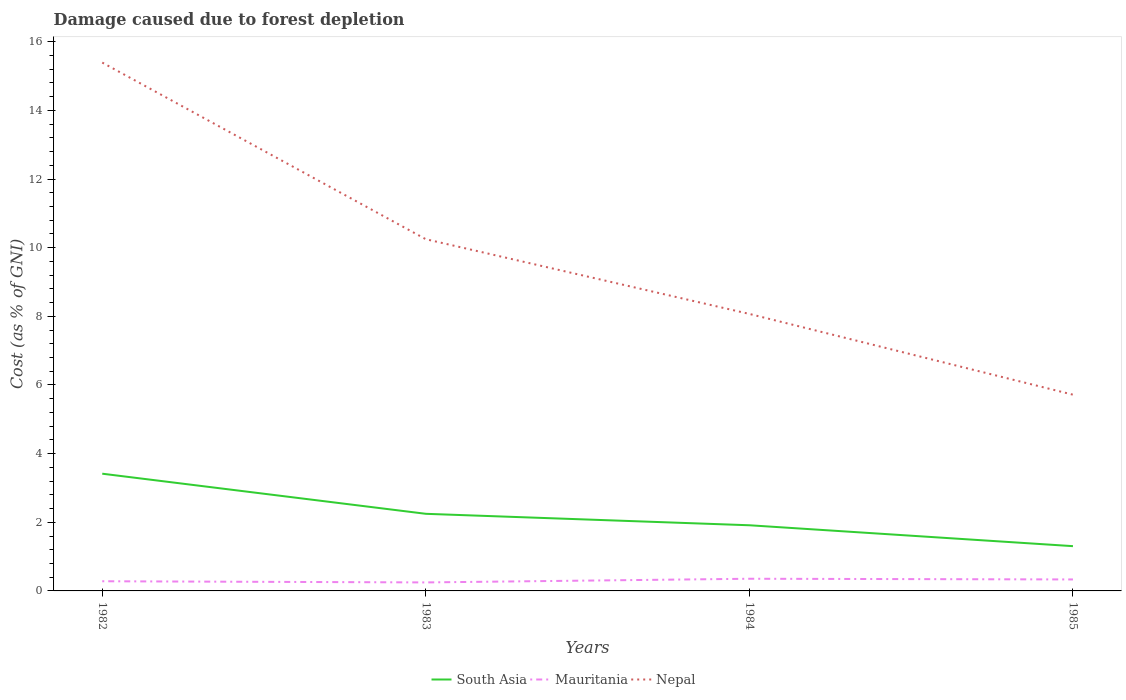Does the line corresponding to South Asia intersect with the line corresponding to Nepal?
Your response must be concise. No. Is the number of lines equal to the number of legend labels?
Make the answer very short. Yes. Across all years, what is the maximum cost of damage caused due to forest depletion in Mauritania?
Offer a very short reply. 0.25. In which year was the cost of damage caused due to forest depletion in South Asia maximum?
Give a very brief answer. 1985. What is the total cost of damage caused due to forest depletion in Mauritania in the graph?
Your answer should be compact. 0.03. What is the difference between the highest and the second highest cost of damage caused due to forest depletion in Nepal?
Your answer should be compact. 9.68. Is the cost of damage caused due to forest depletion in Nepal strictly greater than the cost of damage caused due to forest depletion in South Asia over the years?
Your response must be concise. No. How many lines are there?
Offer a very short reply. 3. Where does the legend appear in the graph?
Offer a very short reply. Bottom center. How many legend labels are there?
Ensure brevity in your answer.  3. How are the legend labels stacked?
Offer a very short reply. Horizontal. What is the title of the graph?
Ensure brevity in your answer.  Damage caused due to forest depletion. Does "Iceland" appear as one of the legend labels in the graph?
Your answer should be very brief. No. What is the label or title of the Y-axis?
Provide a succinct answer. Cost (as % of GNI). What is the Cost (as % of GNI) in South Asia in 1982?
Offer a very short reply. 3.42. What is the Cost (as % of GNI) in Mauritania in 1982?
Ensure brevity in your answer.  0.28. What is the Cost (as % of GNI) in Nepal in 1982?
Offer a very short reply. 15.39. What is the Cost (as % of GNI) of South Asia in 1983?
Provide a short and direct response. 2.25. What is the Cost (as % of GNI) of Mauritania in 1983?
Keep it short and to the point. 0.25. What is the Cost (as % of GNI) of Nepal in 1983?
Provide a short and direct response. 10.25. What is the Cost (as % of GNI) of South Asia in 1984?
Provide a short and direct response. 1.91. What is the Cost (as % of GNI) in Mauritania in 1984?
Offer a very short reply. 0.35. What is the Cost (as % of GNI) of Nepal in 1984?
Provide a succinct answer. 8.07. What is the Cost (as % of GNI) of South Asia in 1985?
Offer a terse response. 1.3. What is the Cost (as % of GNI) of Mauritania in 1985?
Make the answer very short. 0.33. What is the Cost (as % of GNI) in Nepal in 1985?
Your response must be concise. 5.72. Across all years, what is the maximum Cost (as % of GNI) of South Asia?
Offer a very short reply. 3.42. Across all years, what is the maximum Cost (as % of GNI) of Mauritania?
Keep it short and to the point. 0.35. Across all years, what is the maximum Cost (as % of GNI) of Nepal?
Make the answer very short. 15.39. Across all years, what is the minimum Cost (as % of GNI) in South Asia?
Offer a very short reply. 1.3. Across all years, what is the minimum Cost (as % of GNI) in Mauritania?
Provide a succinct answer. 0.25. Across all years, what is the minimum Cost (as % of GNI) in Nepal?
Offer a very short reply. 5.72. What is the total Cost (as % of GNI) of South Asia in the graph?
Your answer should be very brief. 8.88. What is the total Cost (as % of GNI) of Mauritania in the graph?
Your answer should be compact. 1.22. What is the total Cost (as % of GNI) in Nepal in the graph?
Ensure brevity in your answer.  39.43. What is the difference between the Cost (as % of GNI) of South Asia in 1982 and that in 1983?
Your response must be concise. 1.17. What is the difference between the Cost (as % of GNI) in Mauritania in 1982 and that in 1983?
Give a very brief answer. 0.03. What is the difference between the Cost (as % of GNI) in Nepal in 1982 and that in 1983?
Your response must be concise. 5.15. What is the difference between the Cost (as % of GNI) in South Asia in 1982 and that in 1984?
Ensure brevity in your answer.  1.5. What is the difference between the Cost (as % of GNI) of Mauritania in 1982 and that in 1984?
Your answer should be compact. -0.07. What is the difference between the Cost (as % of GNI) in Nepal in 1982 and that in 1984?
Give a very brief answer. 7.32. What is the difference between the Cost (as % of GNI) of South Asia in 1982 and that in 1985?
Keep it short and to the point. 2.11. What is the difference between the Cost (as % of GNI) in Mauritania in 1982 and that in 1985?
Offer a terse response. -0.05. What is the difference between the Cost (as % of GNI) of Nepal in 1982 and that in 1985?
Give a very brief answer. 9.68. What is the difference between the Cost (as % of GNI) of South Asia in 1983 and that in 1984?
Your response must be concise. 0.33. What is the difference between the Cost (as % of GNI) in Mauritania in 1983 and that in 1984?
Your answer should be very brief. -0.11. What is the difference between the Cost (as % of GNI) in Nepal in 1983 and that in 1984?
Offer a terse response. 2.18. What is the difference between the Cost (as % of GNI) of South Asia in 1983 and that in 1985?
Give a very brief answer. 0.94. What is the difference between the Cost (as % of GNI) in Mauritania in 1983 and that in 1985?
Keep it short and to the point. -0.09. What is the difference between the Cost (as % of GNI) of Nepal in 1983 and that in 1985?
Offer a very short reply. 4.53. What is the difference between the Cost (as % of GNI) of South Asia in 1984 and that in 1985?
Provide a short and direct response. 0.61. What is the difference between the Cost (as % of GNI) of Mauritania in 1984 and that in 1985?
Offer a very short reply. 0.02. What is the difference between the Cost (as % of GNI) in Nepal in 1984 and that in 1985?
Provide a succinct answer. 2.35. What is the difference between the Cost (as % of GNI) in South Asia in 1982 and the Cost (as % of GNI) in Mauritania in 1983?
Offer a very short reply. 3.17. What is the difference between the Cost (as % of GNI) of South Asia in 1982 and the Cost (as % of GNI) of Nepal in 1983?
Your response must be concise. -6.83. What is the difference between the Cost (as % of GNI) of Mauritania in 1982 and the Cost (as % of GNI) of Nepal in 1983?
Offer a terse response. -9.97. What is the difference between the Cost (as % of GNI) in South Asia in 1982 and the Cost (as % of GNI) in Mauritania in 1984?
Keep it short and to the point. 3.06. What is the difference between the Cost (as % of GNI) in South Asia in 1982 and the Cost (as % of GNI) in Nepal in 1984?
Keep it short and to the point. -4.66. What is the difference between the Cost (as % of GNI) of Mauritania in 1982 and the Cost (as % of GNI) of Nepal in 1984?
Your answer should be very brief. -7.79. What is the difference between the Cost (as % of GNI) of South Asia in 1982 and the Cost (as % of GNI) of Mauritania in 1985?
Offer a terse response. 3.08. What is the difference between the Cost (as % of GNI) of South Asia in 1982 and the Cost (as % of GNI) of Nepal in 1985?
Your response must be concise. -2.3. What is the difference between the Cost (as % of GNI) of Mauritania in 1982 and the Cost (as % of GNI) of Nepal in 1985?
Your answer should be very brief. -5.44. What is the difference between the Cost (as % of GNI) in South Asia in 1983 and the Cost (as % of GNI) in Mauritania in 1984?
Offer a terse response. 1.89. What is the difference between the Cost (as % of GNI) in South Asia in 1983 and the Cost (as % of GNI) in Nepal in 1984?
Offer a very short reply. -5.82. What is the difference between the Cost (as % of GNI) of Mauritania in 1983 and the Cost (as % of GNI) of Nepal in 1984?
Offer a very short reply. -7.82. What is the difference between the Cost (as % of GNI) in South Asia in 1983 and the Cost (as % of GNI) in Mauritania in 1985?
Provide a succinct answer. 1.91. What is the difference between the Cost (as % of GNI) in South Asia in 1983 and the Cost (as % of GNI) in Nepal in 1985?
Your answer should be very brief. -3.47. What is the difference between the Cost (as % of GNI) of Mauritania in 1983 and the Cost (as % of GNI) of Nepal in 1985?
Offer a very short reply. -5.47. What is the difference between the Cost (as % of GNI) in South Asia in 1984 and the Cost (as % of GNI) in Mauritania in 1985?
Offer a terse response. 1.58. What is the difference between the Cost (as % of GNI) in South Asia in 1984 and the Cost (as % of GNI) in Nepal in 1985?
Provide a succinct answer. -3.8. What is the difference between the Cost (as % of GNI) of Mauritania in 1984 and the Cost (as % of GNI) of Nepal in 1985?
Provide a succinct answer. -5.36. What is the average Cost (as % of GNI) of South Asia per year?
Provide a short and direct response. 2.22. What is the average Cost (as % of GNI) of Mauritania per year?
Offer a very short reply. 0.3. What is the average Cost (as % of GNI) of Nepal per year?
Your response must be concise. 9.86. In the year 1982, what is the difference between the Cost (as % of GNI) of South Asia and Cost (as % of GNI) of Mauritania?
Provide a short and direct response. 3.13. In the year 1982, what is the difference between the Cost (as % of GNI) in South Asia and Cost (as % of GNI) in Nepal?
Ensure brevity in your answer.  -11.98. In the year 1982, what is the difference between the Cost (as % of GNI) in Mauritania and Cost (as % of GNI) in Nepal?
Your answer should be compact. -15.11. In the year 1983, what is the difference between the Cost (as % of GNI) in South Asia and Cost (as % of GNI) in Mauritania?
Provide a short and direct response. 2. In the year 1983, what is the difference between the Cost (as % of GNI) of South Asia and Cost (as % of GNI) of Nepal?
Your response must be concise. -8. In the year 1983, what is the difference between the Cost (as % of GNI) of Mauritania and Cost (as % of GNI) of Nepal?
Provide a short and direct response. -10. In the year 1984, what is the difference between the Cost (as % of GNI) in South Asia and Cost (as % of GNI) in Mauritania?
Your response must be concise. 1.56. In the year 1984, what is the difference between the Cost (as % of GNI) of South Asia and Cost (as % of GNI) of Nepal?
Your response must be concise. -6.16. In the year 1984, what is the difference between the Cost (as % of GNI) in Mauritania and Cost (as % of GNI) in Nepal?
Your response must be concise. -7.72. In the year 1985, what is the difference between the Cost (as % of GNI) of South Asia and Cost (as % of GNI) of Mauritania?
Your response must be concise. 0.97. In the year 1985, what is the difference between the Cost (as % of GNI) in South Asia and Cost (as % of GNI) in Nepal?
Make the answer very short. -4.41. In the year 1985, what is the difference between the Cost (as % of GNI) of Mauritania and Cost (as % of GNI) of Nepal?
Your answer should be very brief. -5.38. What is the ratio of the Cost (as % of GNI) in South Asia in 1982 to that in 1983?
Your answer should be very brief. 1.52. What is the ratio of the Cost (as % of GNI) in Mauritania in 1982 to that in 1983?
Offer a terse response. 1.14. What is the ratio of the Cost (as % of GNI) of Nepal in 1982 to that in 1983?
Ensure brevity in your answer.  1.5. What is the ratio of the Cost (as % of GNI) of South Asia in 1982 to that in 1984?
Make the answer very short. 1.79. What is the ratio of the Cost (as % of GNI) of Mauritania in 1982 to that in 1984?
Your answer should be very brief. 0.79. What is the ratio of the Cost (as % of GNI) of Nepal in 1982 to that in 1984?
Ensure brevity in your answer.  1.91. What is the ratio of the Cost (as % of GNI) of South Asia in 1982 to that in 1985?
Offer a very short reply. 2.62. What is the ratio of the Cost (as % of GNI) in Mauritania in 1982 to that in 1985?
Your answer should be very brief. 0.84. What is the ratio of the Cost (as % of GNI) in Nepal in 1982 to that in 1985?
Your answer should be very brief. 2.69. What is the ratio of the Cost (as % of GNI) in South Asia in 1983 to that in 1984?
Offer a terse response. 1.17. What is the ratio of the Cost (as % of GNI) of Mauritania in 1983 to that in 1984?
Ensure brevity in your answer.  0.7. What is the ratio of the Cost (as % of GNI) in Nepal in 1983 to that in 1984?
Your answer should be very brief. 1.27. What is the ratio of the Cost (as % of GNI) of South Asia in 1983 to that in 1985?
Offer a terse response. 1.72. What is the ratio of the Cost (as % of GNI) of Mauritania in 1983 to that in 1985?
Provide a succinct answer. 0.74. What is the ratio of the Cost (as % of GNI) in Nepal in 1983 to that in 1985?
Give a very brief answer. 1.79. What is the ratio of the Cost (as % of GNI) in South Asia in 1984 to that in 1985?
Keep it short and to the point. 1.47. What is the ratio of the Cost (as % of GNI) of Mauritania in 1984 to that in 1985?
Ensure brevity in your answer.  1.06. What is the ratio of the Cost (as % of GNI) of Nepal in 1984 to that in 1985?
Your answer should be compact. 1.41. What is the difference between the highest and the second highest Cost (as % of GNI) of South Asia?
Offer a very short reply. 1.17. What is the difference between the highest and the second highest Cost (as % of GNI) of Mauritania?
Offer a terse response. 0.02. What is the difference between the highest and the second highest Cost (as % of GNI) of Nepal?
Offer a very short reply. 5.15. What is the difference between the highest and the lowest Cost (as % of GNI) of South Asia?
Your response must be concise. 2.11. What is the difference between the highest and the lowest Cost (as % of GNI) in Mauritania?
Provide a short and direct response. 0.11. What is the difference between the highest and the lowest Cost (as % of GNI) in Nepal?
Your answer should be very brief. 9.68. 